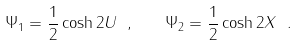<formula> <loc_0><loc_0><loc_500><loc_500>\Psi _ { 1 } = \frac { 1 } { 2 } \cosh { 2 U } \ , \quad \Psi _ { 2 } = \frac { 1 } { 2 } \cosh { 2 X } \ .</formula> 